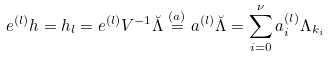Convert formula to latex. <formula><loc_0><loc_0><loc_500><loc_500>e ^ { ( l ) } h & = h _ { l } = e ^ { ( l ) } V ^ { - 1 } \breve { \Lambda } \stackrel { ( a ) } { = } a ^ { ( l ) } \breve { \Lambda } = \sum _ { i = 0 } ^ { \nu } a _ { i } ^ { ( l ) } \Lambda _ { k _ { i } }</formula> 